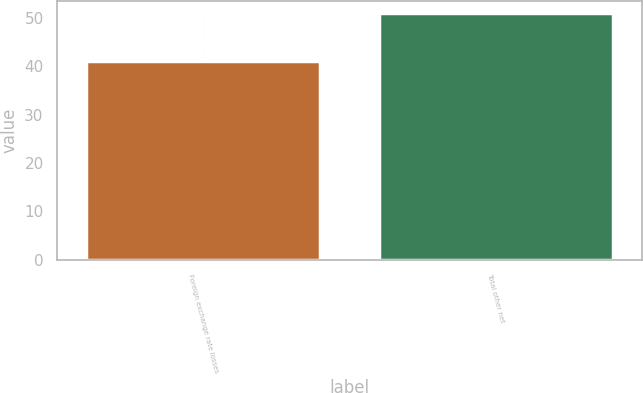Convert chart. <chart><loc_0><loc_0><loc_500><loc_500><bar_chart><fcel>Foreign exchange rate losses<fcel>Total other net<nl><fcel>41<fcel>51<nl></chart> 